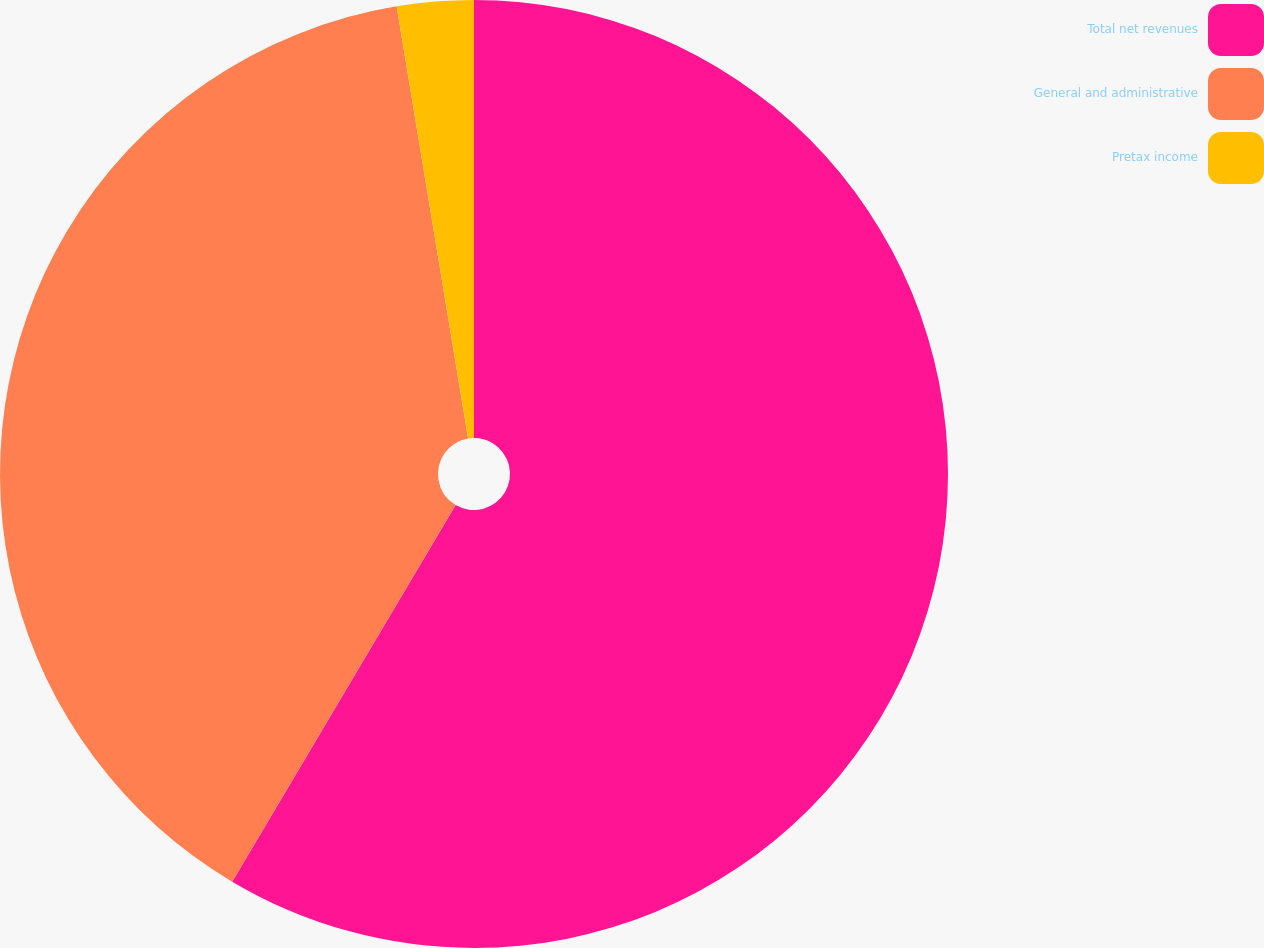<chart> <loc_0><loc_0><loc_500><loc_500><pie_chart><fcel>Total net revenues<fcel>General and administrative<fcel>Pretax income<nl><fcel>58.52%<fcel>38.87%<fcel>2.61%<nl></chart> 